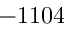Convert formula to latex. <formula><loc_0><loc_0><loc_500><loc_500>- 1 1 0 4</formula> 